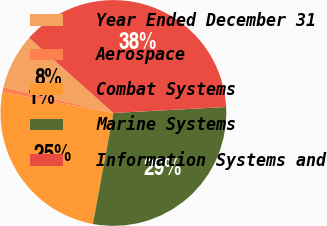Convert chart. <chart><loc_0><loc_0><loc_500><loc_500><pie_chart><fcel>Year Ended December 31<fcel>Aerospace<fcel>Combat Systems<fcel>Marine Systems<fcel>Information Systems and<nl><fcel>7.95%<fcel>0.68%<fcel>25.06%<fcel>28.75%<fcel>37.56%<nl></chart> 